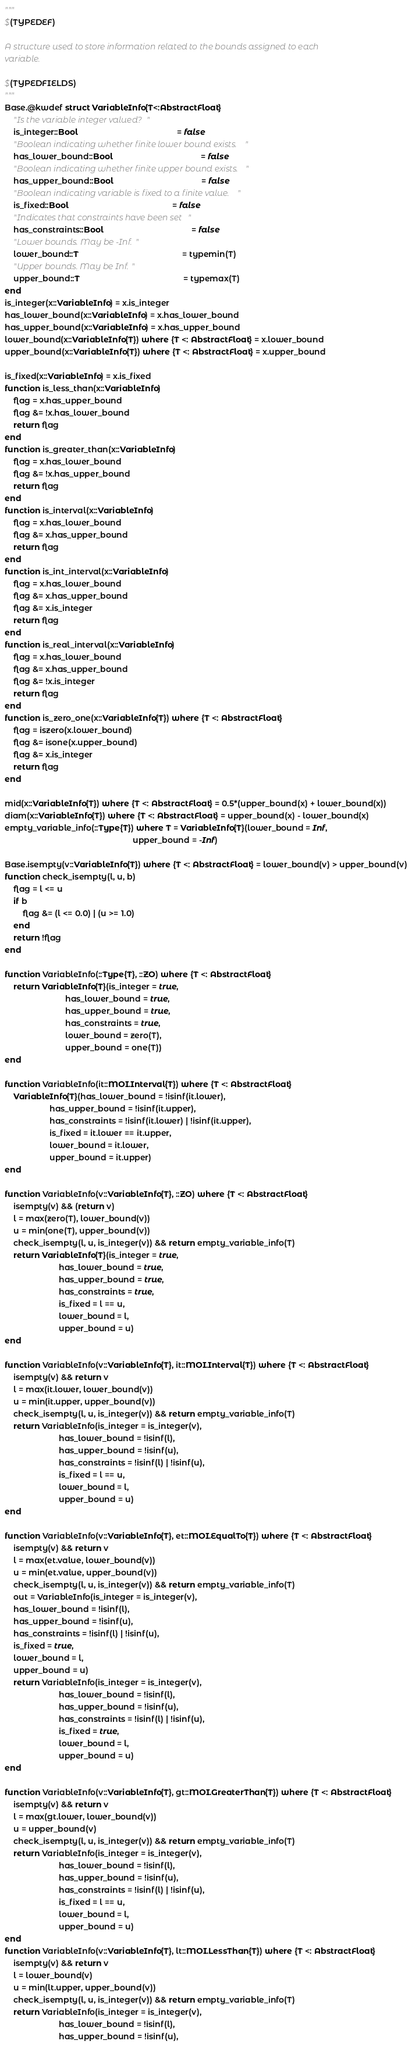<code> <loc_0><loc_0><loc_500><loc_500><_Julia_>"""
$(TYPEDEF)

A structure used to store information related to the bounds assigned to each
variable.

$(TYPEDFIELDS)
"""
Base.@kwdef struct VariableInfo{T<:AbstractFloat}
    "Is the variable integer valued?"
    is_integer::Bool                                            = false
    "Boolean indicating whether finite lower bound exists."
    has_lower_bound::Bool                                       = false
    "Boolean indicating whether finite upper bound exists."
    has_upper_bound::Bool                                       = false
    "Boolean indicating variable is fixed to a finite value."
    is_fixed::Bool                                              = false
    "Indicates that constraints have been set"
    has_constraints::Bool                                       = false
    "Lower bounds. May be -Inf."
    lower_bound::T                                              = typemin(T)
    "Upper bounds. May be Inf."
    upper_bound::T                                              = typemax(T)
end
is_integer(x::VariableInfo) = x.is_integer
has_lower_bound(x::VariableInfo) = x.has_lower_bound
has_upper_bound(x::VariableInfo) = x.has_upper_bound
lower_bound(x::VariableInfo{T}) where {T <: AbstractFloat} = x.lower_bound
upper_bound(x::VariableInfo{T}) where {T <: AbstractFloat} = x.upper_bound

is_fixed(x::VariableInfo) = x.is_fixed
function is_less_than(x::VariableInfo)
    flag = x.has_upper_bound
    flag &= !x.has_lower_bound
    return flag
end
function is_greater_than(x::VariableInfo)
    flag = x.has_lower_bound
    flag &= !x.has_upper_bound
    return flag
end
function is_interval(x::VariableInfo)
    flag = x.has_lower_bound
    flag &= x.has_upper_bound
    return flag
end
function is_int_interval(x::VariableInfo)
    flag = x.has_lower_bound
    flag &= x.has_upper_bound
    flag &= x.is_integer
    return flag
end
function is_real_interval(x::VariableInfo)
    flag = x.has_lower_bound
    flag &= x.has_upper_bound
    flag &= !x.is_integer
    return flag
end
function is_zero_one(x::VariableInfo{T}) where {T <: AbstractFloat}
    flag = iszero(x.lower_bound)
    flag &= isone(x.upper_bound)
    flag &= x.is_integer
    return flag
end

mid(x::VariableInfo{T}) where {T <: AbstractFloat} = 0.5*(upper_bound(x) + lower_bound(x))
diam(x::VariableInfo{T}) where {T <: AbstractFloat} = upper_bound(x) - lower_bound(x)
empty_variable_info(::Type{T}) where T = VariableInfo{T}(lower_bound = Inf,
                                                         upper_bound = -Inf)

Base.isempty(v::VariableInfo{T}) where {T <: AbstractFloat} = lower_bound(v) > upper_bound(v)
function check_isempty(l, u, b)
    flag = l <= u
    if b
        flag &= (l <= 0.0) | (u >= 1.0)
    end
    return !flag
end

function VariableInfo(::Type{T}, ::ZO) where {T <: AbstractFloat}
    return VariableInfo{T}(is_integer = true,
                           has_lower_bound = true,
                           has_upper_bound = true,
                           has_constraints = true,
                           lower_bound = zero(T),
                           upper_bound = one(T))
end

function VariableInfo(it::MOI.Interval{T}) where {T <: AbstractFloat}
    VariableInfo{T}(has_lower_bound = !isinf(it.lower),
                    has_upper_bound = !isinf(it.upper),
                    has_constraints = !isinf(it.lower) | !isinf(it.upper),
                    is_fixed = it.lower == it.upper,
                    lower_bound = it.lower,
                    upper_bound = it.upper)
end

function VariableInfo(v::VariableInfo{T}, ::ZO) where {T <: AbstractFloat}
    isempty(v) && (return v)
    l = max(zero(T), lower_bound(v))
    u = min(one(T), upper_bound(v))
    check_isempty(l, u, is_integer(v)) && return empty_variable_info(T)
    return VariableInfo{T}(is_integer = true,
                        has_lower_bound = true,
                        has_upper_bound = true,
                        has_constraints = true,
                        is_fixed = l == u,
                        lower_bound = l,
                        upper_bound = u)
end

function VariableInfo(v::VariableInfo{T}, it::MOI.Interval{T}) where {T <: AbstractFloat}
    isempty(v) && return v
    l = max(it.lower, lower_bound(v))
    u = min(it.upper, upper_bound(v))
    check_isempty(l, u, is_integer(v)) && return empty_variable_info(T)
    return VariableInfo(is_integer = is_integer(v),
                        has_lower_bound = !isinf(l),
                        has_upper_bound = !isinf(u),
                        has_constraints = !isinf(l) | !isinf(u),
                        is_fixed = l == u,
                        lower_bound = l,
                        upper_bound = u)
end

function VariableInfo(v::VariableInfo{T}, et::MOI.EqualTo{T}) where {T <: AbstractFloat}
    isempty(v) && return v
    l = max(et.value, lower_bound(v))
    u = min(et.value, upper_bound(v))
    check_isempty(l, u, is_integer(v)) && return empty_variable_info(T)
    out = VariableInfo(is_integer = is_integer(v),
    has_lower_bound = !isinf(l),
    has_upper_bound = !isinf(u),
    has_constraints = !isinf(l) | !isinf(u),
    is_fixed = true,
    lower_bound = l,
    upper_bound = u)
    return VariableInfo(is_integer = is_integer(v),
                        has_lower_bound = !isinf(l),
                        has_upper_bound = !isinf(u),
                        has_constraints = !isinf(l) | !isinf(u),
                        is_fixed = true,
                        lower_bound = l,
                        upper_bound = u)
end

function VariableInfo(v::VariableInfo{T}, gt::MOI.GreaterThan{T}) where {T <: AbstractFloat}
    isempty(v) && return v
    l = max(gt.lower, lower_bound(v))
    u = upper_bound(v)
    check_isempty(l, u, is_integer(v)) && return empty_variable_info(T)
    return VariableInfo(is_integer = is_integer(v),
                        has_lower_bound = !isinf(l),
                        has_upper_bound = !isinf(u),
                        has_constraints = !isinf(l) | !isinf(u),
                        is_fixed = l == u,
                        lower_bound = l,
                        upper_bound = u)
end
function VariableInfo(v::VariableInfo{T}, lt::MOI.LessThan{T}) where {T <: AbstractFloat}
    isempty(v) && return v
    l = lower_bound(v)
    u = min(lt.upper, upper_bound(v))
    check_isempty(l, u, is_integer(v)) && return empty_variable_info(T)
    return VariableInfo(is_integer = is_integer(v),
                        has_lower_bound = !isinf(l),
                        has_upper_bound = !isinf(u),</code> 